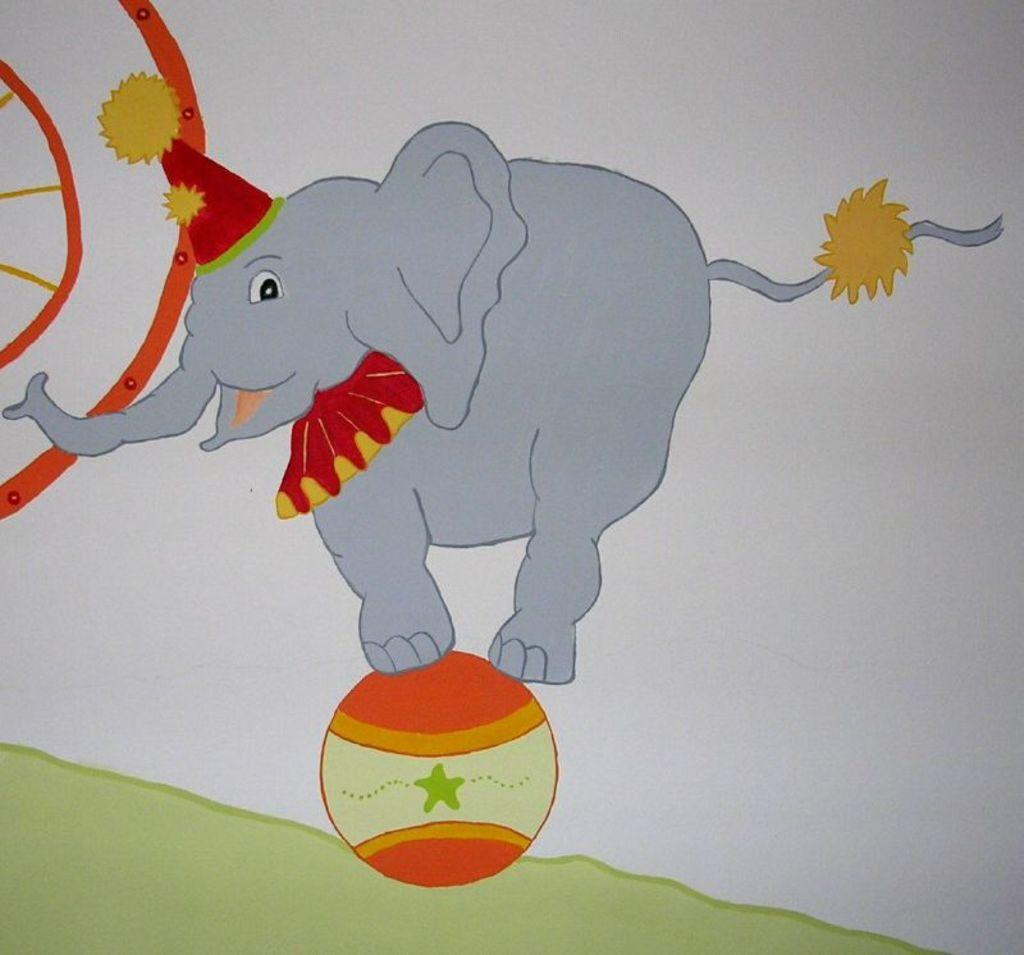What is the main subject of the image? The image contains a painting. What animal is depicted in the painting? There is an elephant in the painting. What is the elephant doing in the painting? The elephant is on a ball. Can you describe the object on the left side of the painting? There is a round object on the left side of the painting. What type of apparatus is the elephant using in the painting? There is no apparatus mentioned in the facts about the image. 